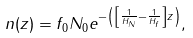Convert formula to latex. <formula><loc_0><loc_0><loc_500><loc_500>n ( z ) = f _ { 0 } N _ { 0 } e ^ { - \left ( \left [ \frac { 1 } { H _ { N } } - \frac { 1 } { H _ { f } } \right ] z \right ) } ,</formula> 